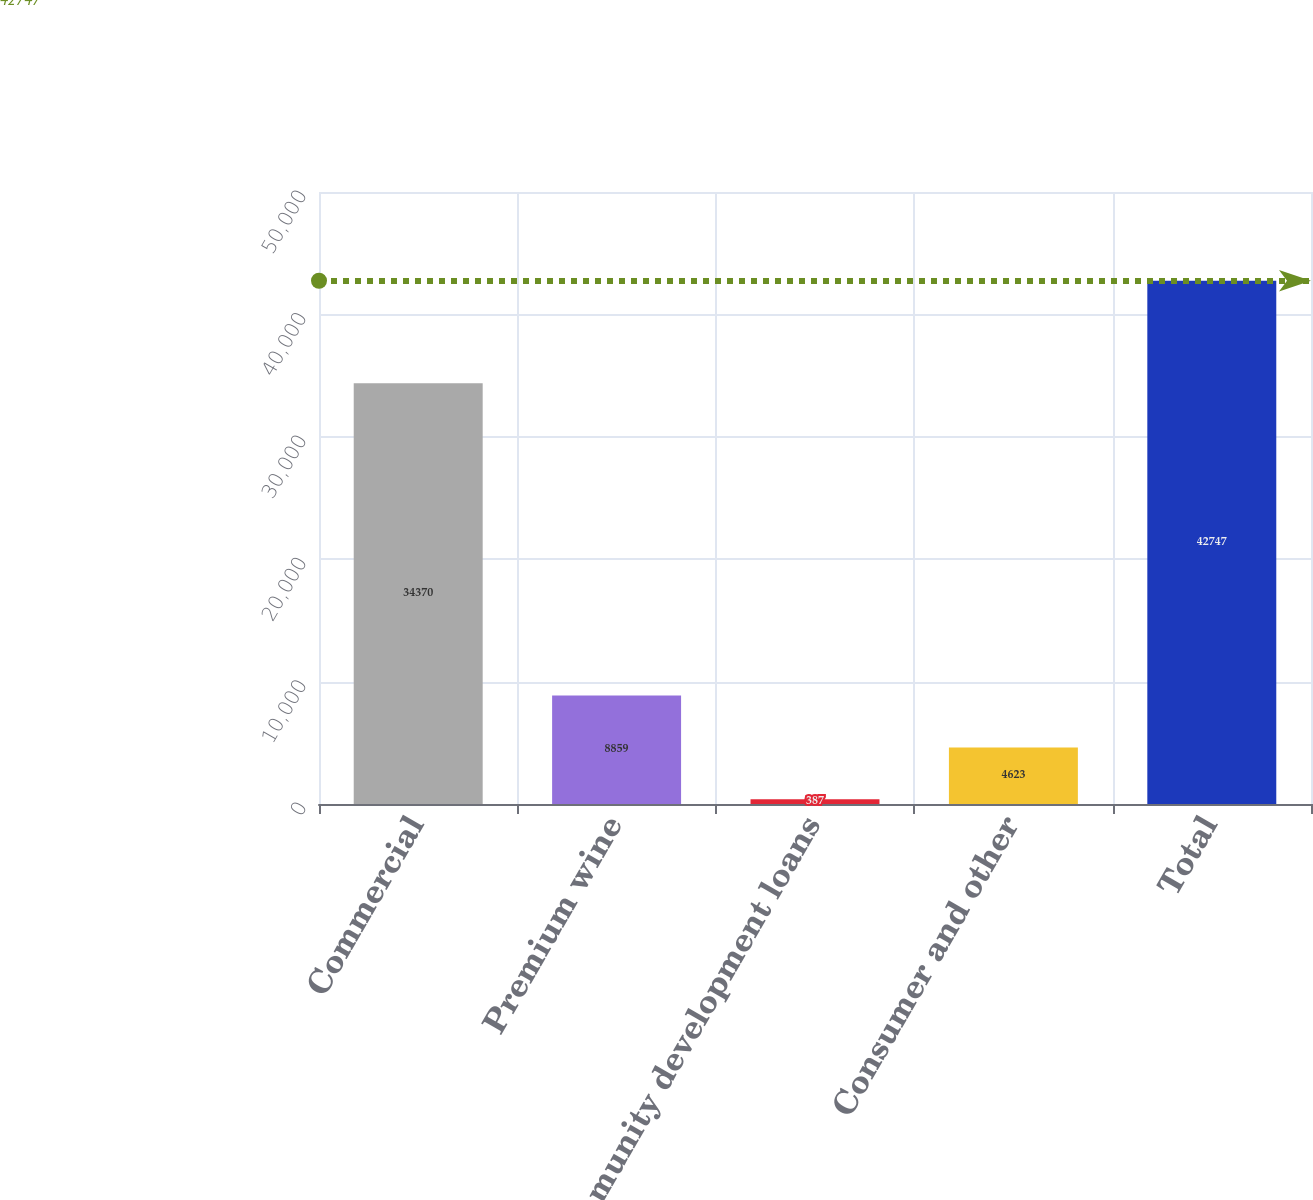Convert chart. <chart><loc_0><loc_0><loc_500><loc_500><bar_chart><fcel>Commercial<fcel>Premium wine<fcel>Community development loans<fcel>Consumer and other<fcel>Total<nl><fcel>34370<fcel>8859<fcel>387<fcel>4623<fcel>42747<nl></chart> 